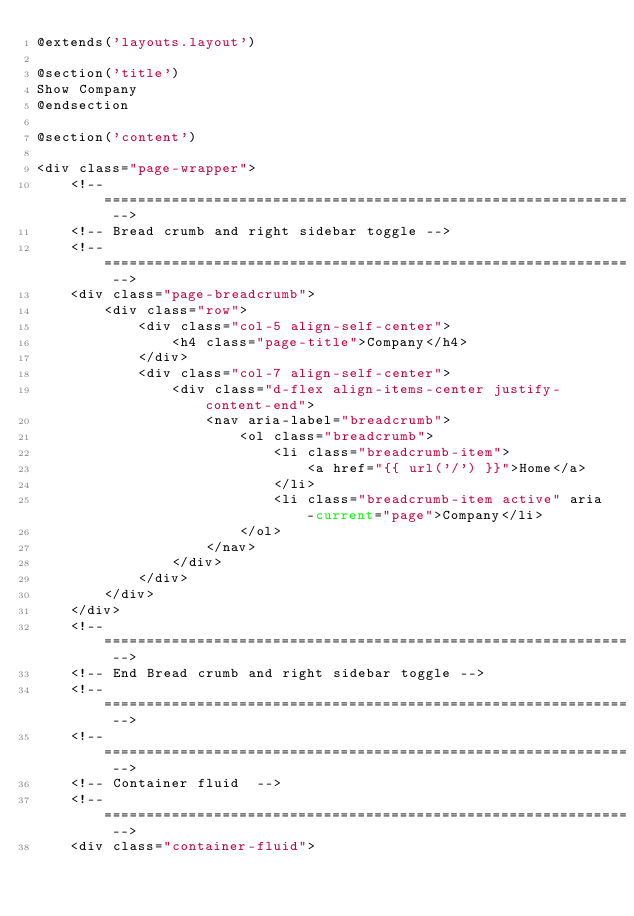Convert code to text. <code><loc_0><loc_0><loc_500><loc_500><_PHP_>@extends('layouts.layout')

@section('title')
Show Company
@endsection

@section('content')

<div class="page-wrapper">
    <!-- ============================================================== -->
    <!-- Bread crumb and right sidebar toggle -->
    <!-- ============================================================== -->
    <div class="page-breadcrumb">
        <div class="row">
            <div class="col-5 align-self-center">
                <h4 class="page-title">Company</h4>
            </div>
            <div class="col-7 align-self-center">
                <div class="d-flex align-items-center justify-content-end">
                    <nav aria-label="breadcrumb">
                        <ol class="breadcrumb">
                            <li class="breadcrumb-item">
                                <a href="{{ url('/') }}">Home</a>
                            </li>
                            <li class="breadcrumb-item active" aria-current="page">Company</li>
                        </ol>
                    </nav>
                </div>
            </div>
        </div>
    </div>
    <!-- ============================================================== -->
    <!-- End Bread crumb and right sidebar toggle -->
    <!-- ============================================================== -->
    <!-- ============================================================== -->
    <!-- Container fluid  -->
    <!-- ============================================================== -->
    <div class="container-fluid"></code> 